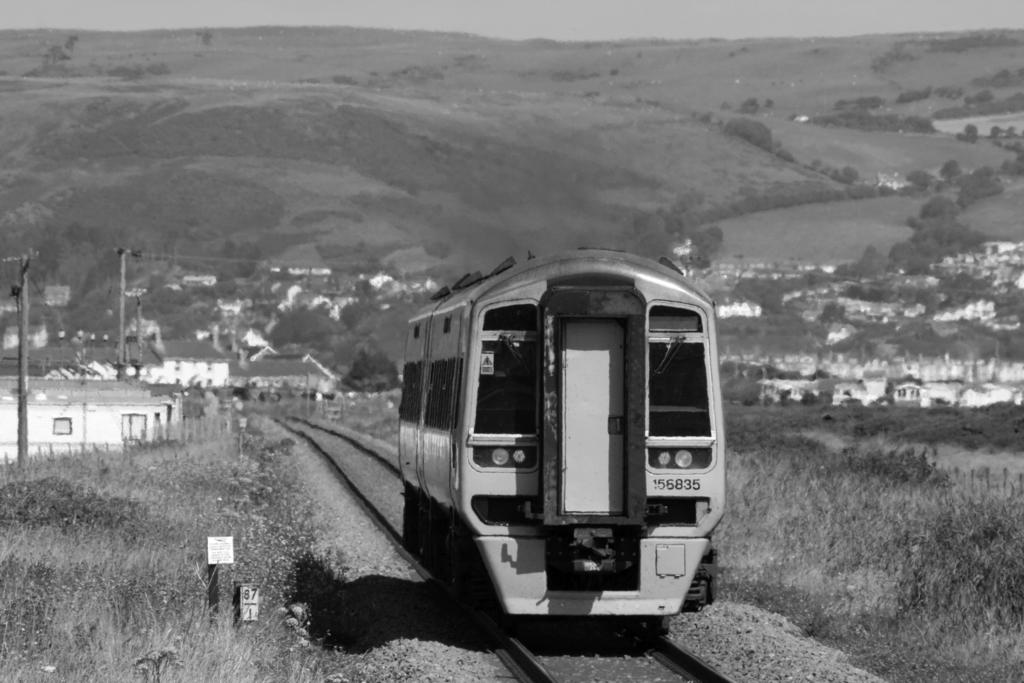What is the color scheme of the image? The image is black and white. What is the main subject of the image? There is a train in the image. Where is the train located in the image? The train is on a railway track. What can be seen in the background of the image? There are trees, mountains, houses, and current poles in the background of the image. Can you see a boat in the image? No, there is no boat present in the image. What is the elbow's role in the train's movement in the image? There is no elbow mentioned or depicted in the image, as it is a black and white image of a train on a railway track with various background elements. 